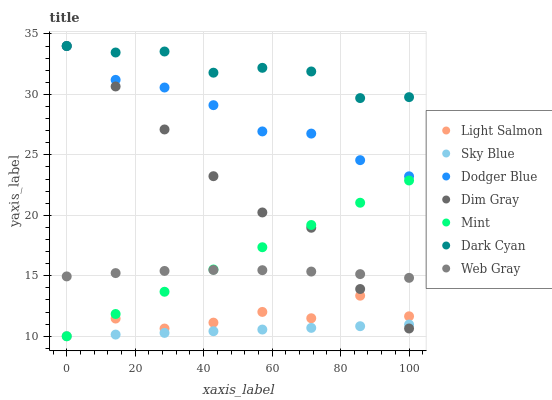Does Sky Blue have the minimum area under the curve?
Answer yes or no. Yes. Does Dark Cyan have the maximum area under the curve?
Answer yes or no. Yes. Does Dim Gray have the minimum area under the curve?
Answer yes or no. No. Does Dim Gray have the maximum area under the curve?
Answer yes or no. No. Is Sky Blue the smoothest?
Answer yes or no. Yes. Is Light Salmon the roughest?
Answer yes or no. Yes. Is Dim Gray the smoothest?
Answer yes or no. No. Is Dim Gray the roughest?
Answer yes or no. No. Does Light Salmon have the lowest value?
Answer yes or no. Yes. Does Dim Gray have the lowest value?
Answer yes or no. No. Does Dark Cyan have the highest value?
Answer yes or no. Yes. Does Web Gray have the highest value?
Answer yes or no. No. Is Light Salmon less than Dark Cyan?
Answer yes or no. Yes. Is Dark Cyan greater than Sky Blue?
Answer yes or no. Yes. Does Light Salmon intersect Sky Blue?
Answer yes or no. Yes. Is Light Salmon less than Sky Blue?
Answer yes or no. No. Is Light Salmon greater than Sky Blue?
Answer yes or no. No. Does Light Salmon intersect Dark Cyan?
Answer yes or no. No. 